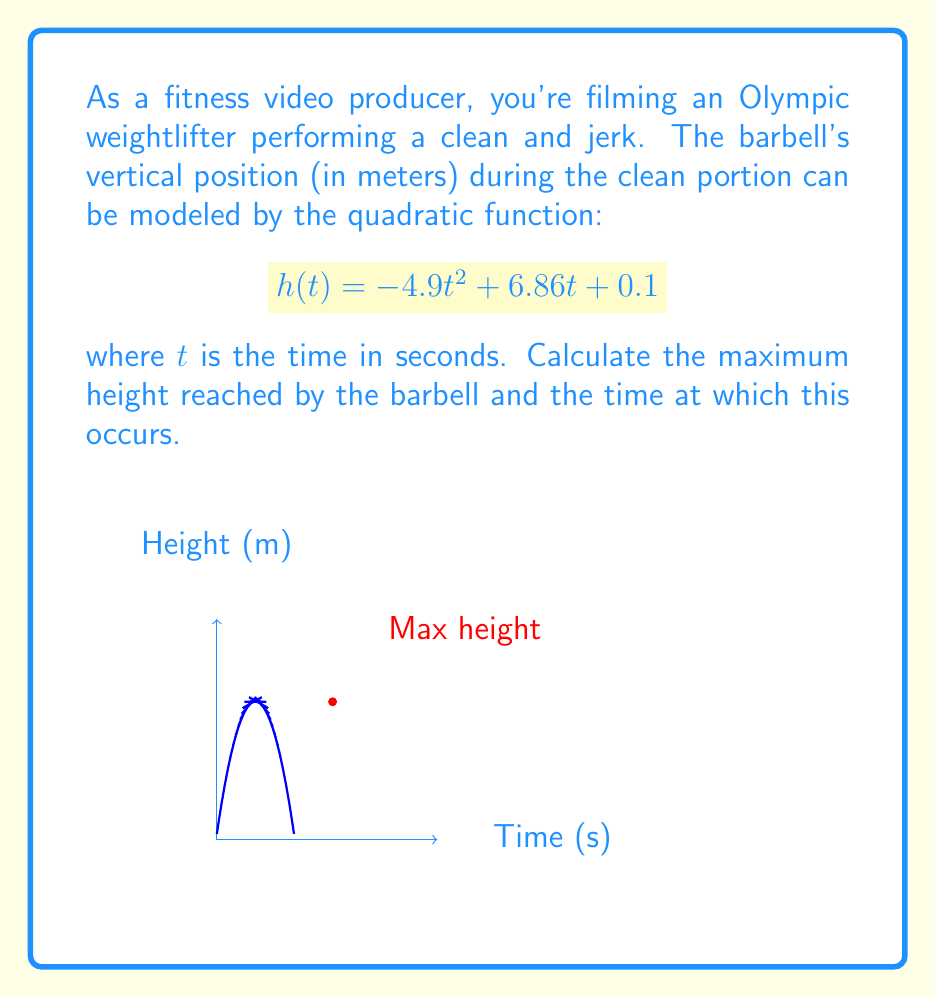Solve this math problem. To solve this problem, we'll follow these steps:

1) The maximum height occurs at the vertex of the parabola. For a quadratic function in the form $f(x) = ax^2 + bx + c$, the x-coordinate of the vertex is given by $x = -\frac{b}{2a}$.

2) In our function $h(t) = -4.9t^2 + 6.86t + 0.1$, we have:
   $a = -4.9$
   $b = 6.86$
   $c = 0.1$

3) Let's calculate the time at which the maximum height occurs:

   $t = -\frac{b}{2a} = -\frac{6.86}{2(-4.9)} = \frac{6.86}{9.8} = 0.7$ seconds

4) To find the maximum height, we substitute this t-value back into our original function:

   $h(0.7) = -4.9(0.7)^2 + 6.86(0.7) + 0.1$
           $= -4.9(0.49) + 6.86(0.7) + 0.1$
           $= -2.401 + 4.802 + 0.1$
           $= 2.501$ meters

5) Therefore, the maximum height reached is approximately 2.5 meters at 0.7 seconds.
Answer: Maximum height: 2.5 m at t = 0.7 s 